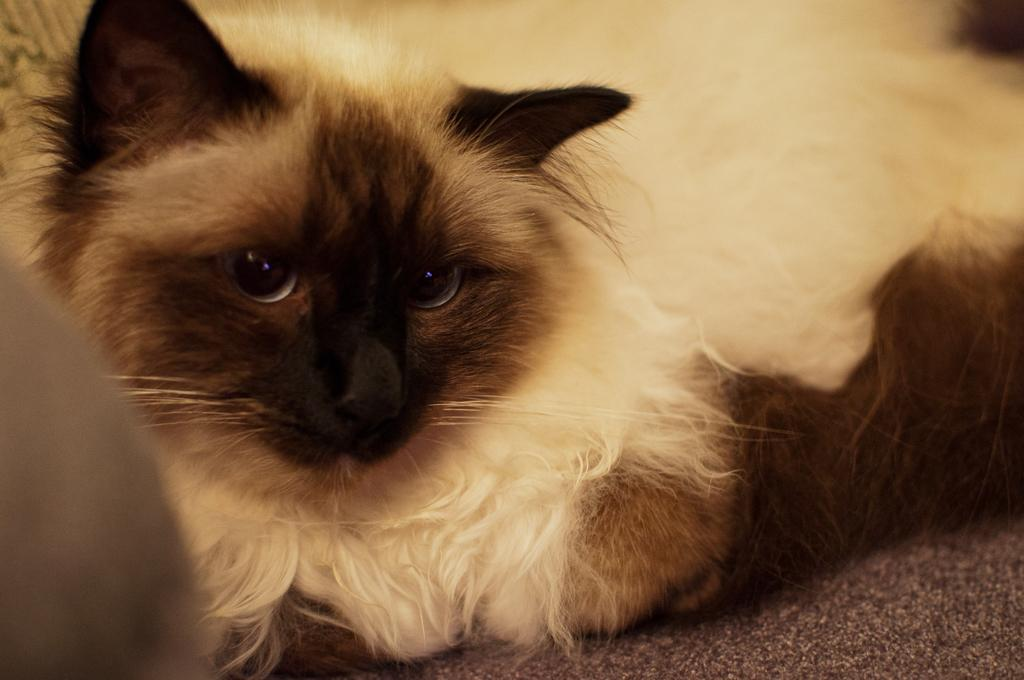What type of animal is in the image? There is a cat in the image. What is the cat doing in the image? The cat is sitting on a surface. What is the color pattern of the cat? The cat is black and white in color. How much quartz can be seen in the image? There is no quartz present in the image. What type of vehicle is driving in the image? There is no vehicle present in the image. 